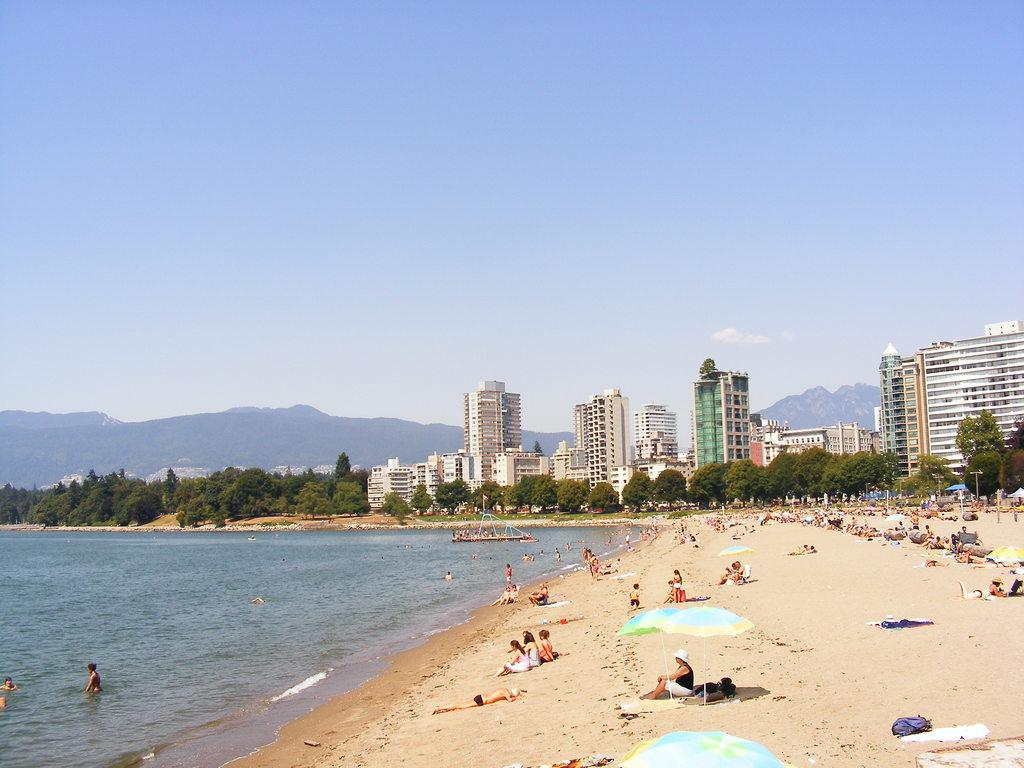What type of location is shown in the image? The image depicts a beach. What are the people on the beach doing? There are people laying on the sand. Are there any structures near the beach? Yes, there are buildings near the beach. What type of vegetation is near the beach? There are trees near the beach. What can be seen in the distance behind the beach? There are mountains visible in the background. What type of knot is being used to secure the boat on the beach? There is no boat present in the image, so it is not possible to determine what type of knot might be used. 